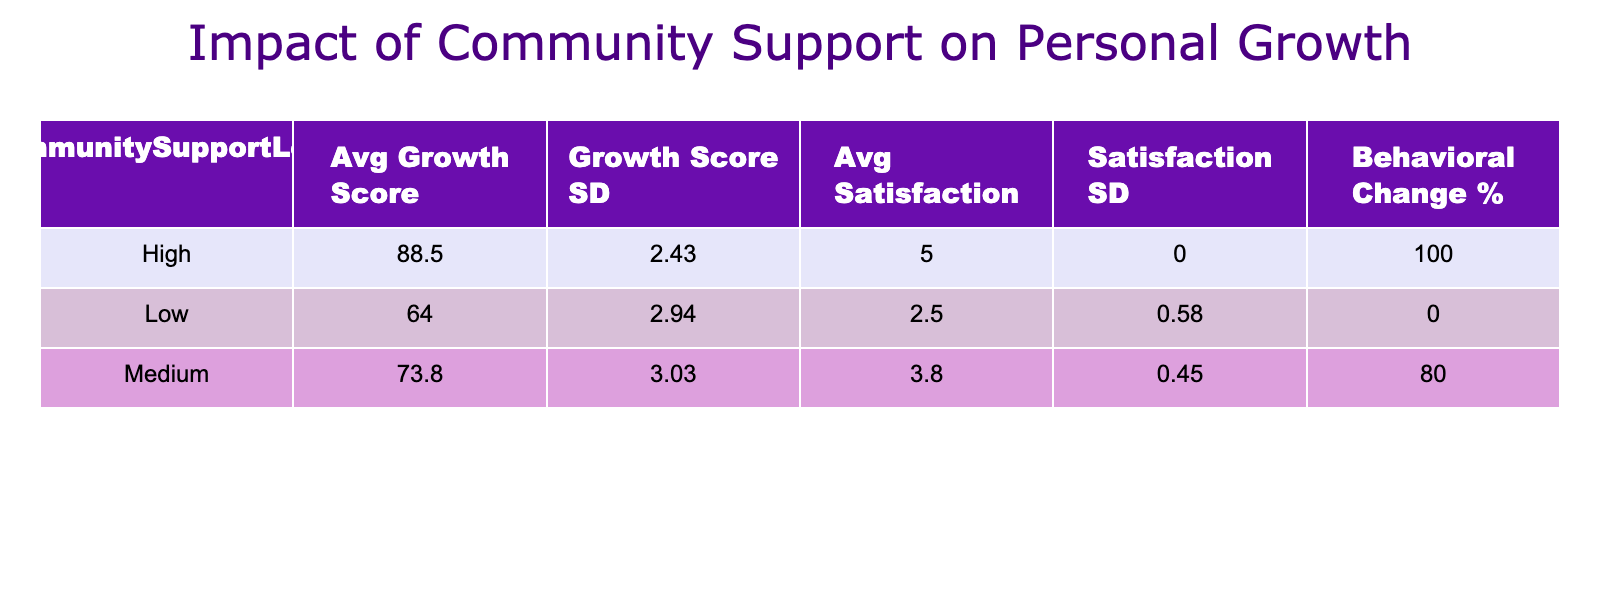What is the average Personal Growth Score for participants with High Community Support? To find the average Personal Growth Score for the High Community Support group, I look at the Personal Growth Scores for these participants: 88, 90, 85, 92, 87, 89. Adding these values gives 88 + 90 + 85 + 92 + 87 + 89 = 521. There are 6 participants in this group, so the average is 521 / 6 = 86.83.
Answer: 86.83 What is the Behavioral Change percentage for participants with Low Community Support? For the Low Community Support group, there are three participants, and two of them reported a Behavioral Change (Yes). To find the percentage, I calculate (2 / 3) * 100 = 66.67.
Answer: 66.67 Which Community Support Level has the highest average Program Satisfaction? Reviewing the average Program Satisfaction values for each support level: High = 5, Medium = 4, and Low = 3. The High Community Support group has the highest average Program Satisfaction score of 5.
Answer: High Is there a participant with Low Community Support who reported a Behavioral Change? Checking the participants with Low Community Support, all of them (3 participants) reported 'No' for Behavioral Change. Therefore, there is no participant with Low Community Support that has indicated a Behavioral Change.
Answer: No What is the difference between the average Personal Growth Score of the High and Medium Community Support levels? The average Personal Growth Score for the High Community Support is 86.83 and for the Medium Community Support is 75. To find the difference, I subtract: 86.83 - 75 = 11.83.
Answer: 11.83 How many participants expressed satisfaction at a level of 5? Evaluating the Program Satisfaction, five participants reported a satisfaction level of 5: IDs 1, 4, 6, 9, and 12. Thus, the total is 5 participants.
Answer: 5 Are there more males or females in the Medium Community Support group? Reviewing the Medium Community Support group, there are three participants: one male (Participant 2) and two females (Participants 5 and 10). Therefore, there are more females (2) than males (1) in this group.
Answer: Females What is the average age of participants who reported Yes for Behavioral Change? Participants who reported Yes for Behavioral Change are: 1 (34), 2 (27), 4 (39), 5 (50), 6 (29), 9 (36), 10 (28), 12 (33), and 14 (29). The total age is 34 + 27 + 39 + 50 + 29 + 36 + 28 + 33 + 29 =  305. There are 9 participants, so the average age is 305 / 9 = 33.89.
Answer: 33.89 